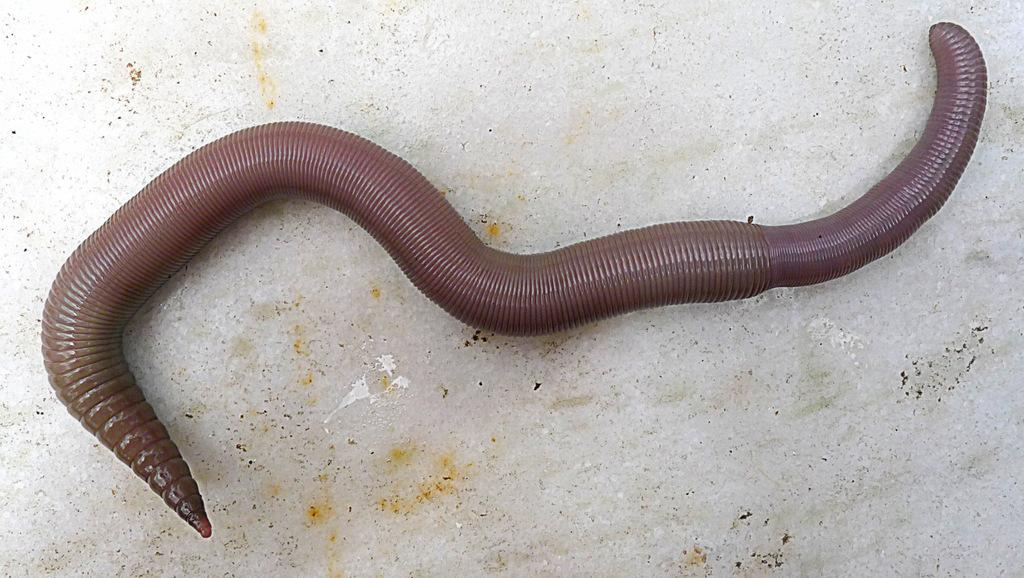What type of animal is in the image? There is an earthworm in the image. What color is the earthworm? The earthworm is brown in color. What is the surface at the bottom of the image? There is a floor at the bottom of the image. What song is the earthworm singing in the image? There is no indication in the image that the earthworm is singing a song. 